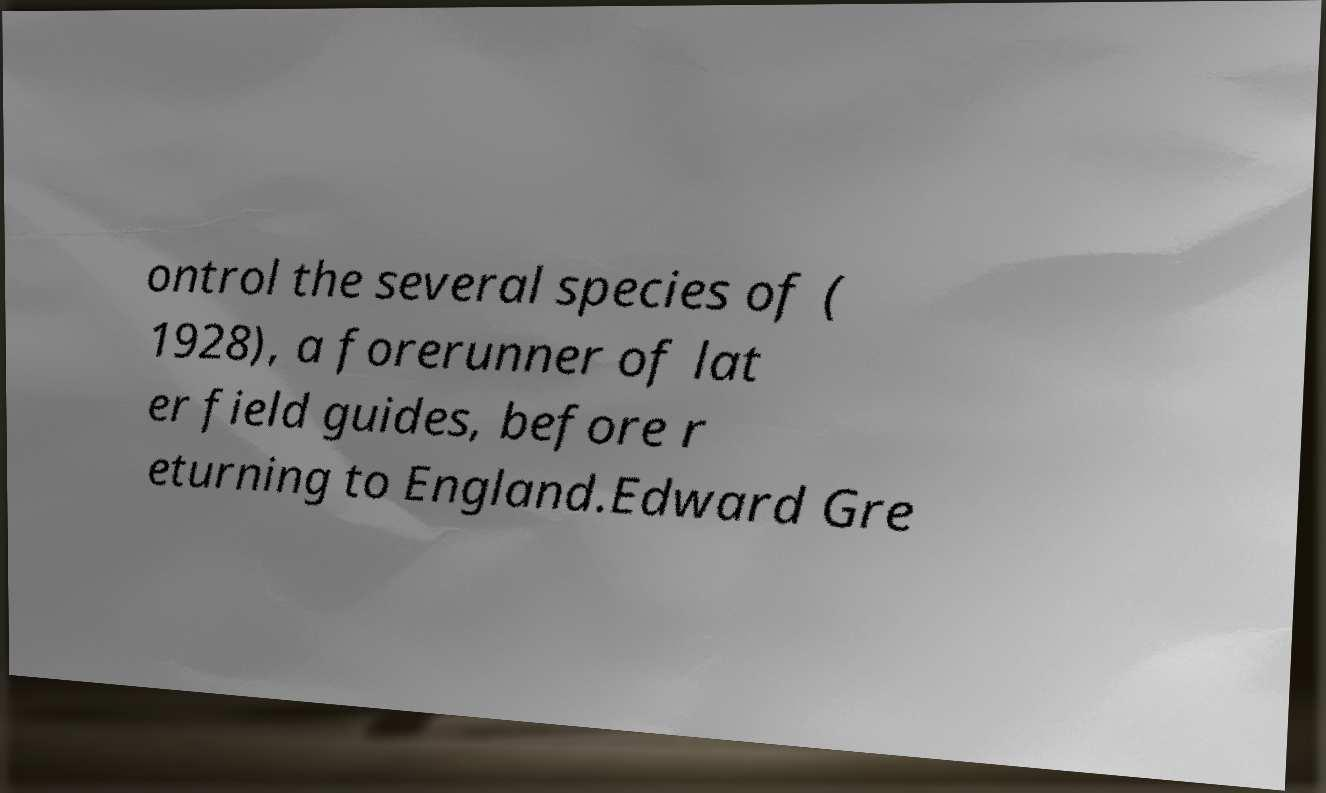There's text embedded in this image that I need extracted. Can you transcribe it verbatim? ontrol the several species of ( 1928), a forerunner of lat er field guides, before r eturning to England.Edward Gre 